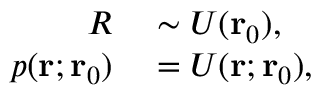<formula> <loc_0><loc_0><loc_500><loc_500>\begin{array} { r l } { R } & \sim U ( r _ { 0 } ) , } \\ { p ( r ; r _ { 0 } ) } & = U ( r ; r _ { 0 } ) , } \end{array}</formula> 